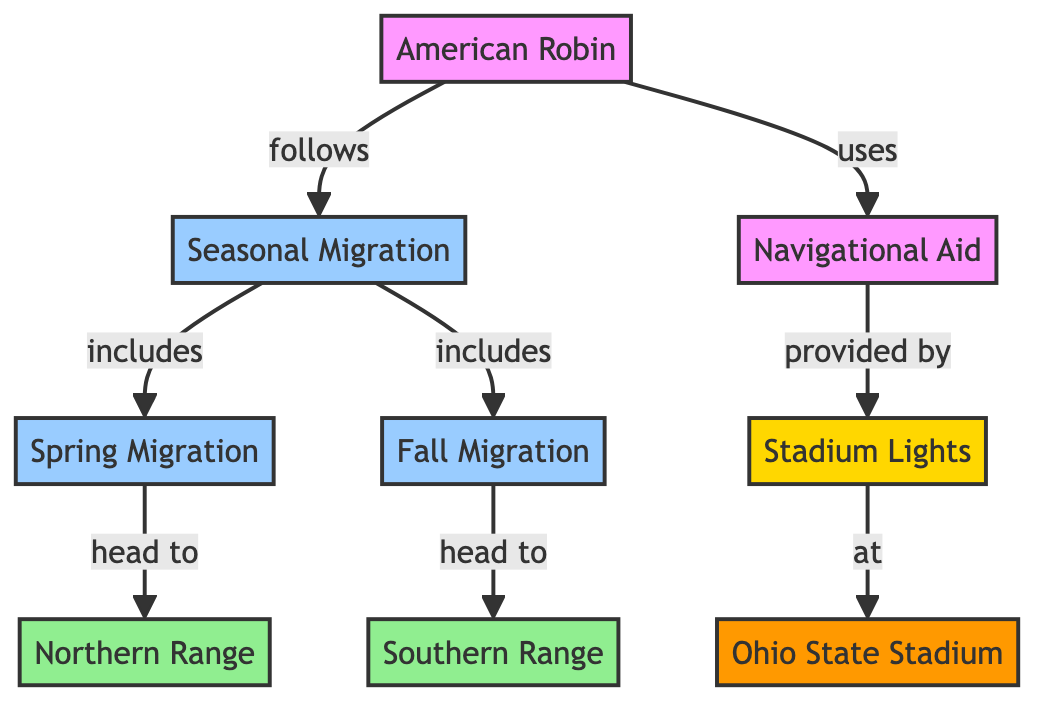What is the main subject of the diagram? The diagram primarily focuses on the "American Robin," which is explicitly mentioned as the main node.
Answer: American Robin How many distinct migration events are included in the diagram? There are two distinct migration events reported: "Spring Migration" and "Fall Migration," which are listed as part of "Seasonal Migration."
Answer: 2 Where does the American Robin migrate to in the spring? According to the diagram, in the spring, the American Robin migrates to the "Northern Range," which is explicitly linked from the "Spring Migration" node.
Answer: Northern Range What navigational aid does the American Robin utilize? The navigational aid used by the American Robin is the "Stadium Lights," which is shown to be connected directly to the American Robin's navigation process.
Answer: Stadium Lights Which stadium is mentioned in the diagram related to migratory behavior? The diagram includes "Ohio State Stadium," which is noted as the location related to stadium lights that aid in navigation.
Answer: Ohio State Stadium How is the relationship between Season Migration and American Robin described? "Seasonal Migration" is illustrated as a concept that the "American Robin" follows, indicating a direct connection where the robin's behavior is dependent on this migration pattern.
Answer: Follows What does the "Fall Migration" lead the American Robin towards? The diagram indicates that the "Fall Migration" leads the American Robin to the "Southern Range," as shown in the flow from Fall Migration to Southern Range.
Answer: Southern Range What is the role of stadium lights in the context of the American Robin's migration? The role of stadium lights is that they serve as a navigational aid for the American Robin, denoted in the diagram as an essential component for navigation.
Answer: Navigational Aid How many total nodes are there in the diagram? The diagram consists of nine total nodes, including the main subjects and connections depicted in the flowchart.
Answer: 9 